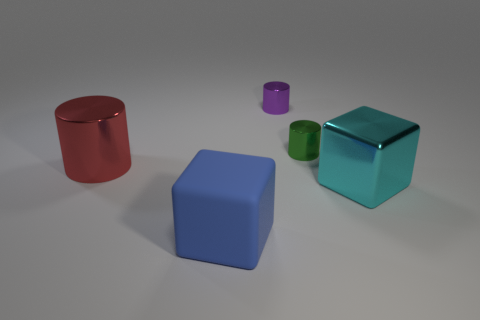Does the large cyan thing have the same material as the red thing?
Provide a succinct answer. Yes. Is the number of big metallic cylinders on the left side of the big cyan metallic block less than the number of big objects on the right side of the purple metallic cylinder?
Offer a terse response. No. There is a cube left of the big cyan block on the right side of the tiny green thing; what number of tiny green things are in front of it?
Offer a very short reply. 0. Does the big metal cylinder have the same color as the rubber thing?
Offer a terse response. No. Are there any other big cubes of the same color as the big shiny block?
Offer a terse response. No. There is a matte object that is the same size as the red shiny thing; what color is it?
Ensure brevity in your answer.  Blue. Are there any green metal objects of the same shape as the purple shiny object?
Offer a terse response. Yes. There is a block left of the small cylinder on the left side of the small green metal object; is there a blue matte object that is to the right of it?
Your response must be concise. No. There is a purple shiny object that is the same size as the green object; what is its shape?
Your response must be concise. Cylinder. There is another object that is the same shape as the cyan thing; what is its color?
Make the answer very short. Blue. 